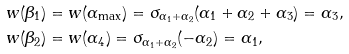<formula> <loc_0><loc_0><loc_500><loc_500>& w ( \beta _ { 1 } ) = w ( \alpha _ { \max } ) = \sigma _ { \alpha _ { 1 } + \alpha _ { 2 } } ( \alpha _ { 1 } + \alpha _ { 2 } + \alpha _ { 3 } ) = \alpha _ { 3 } , \\ & w ( \beta _ { 2 } ) = w ( \alpha _ { 4 } ) = \sigma _ { \alpha _ { 1 } + \alpha _ { 2 } } ( - \alpha _ { 2 } ) = \alpha _ { 1 } ,</formula> 